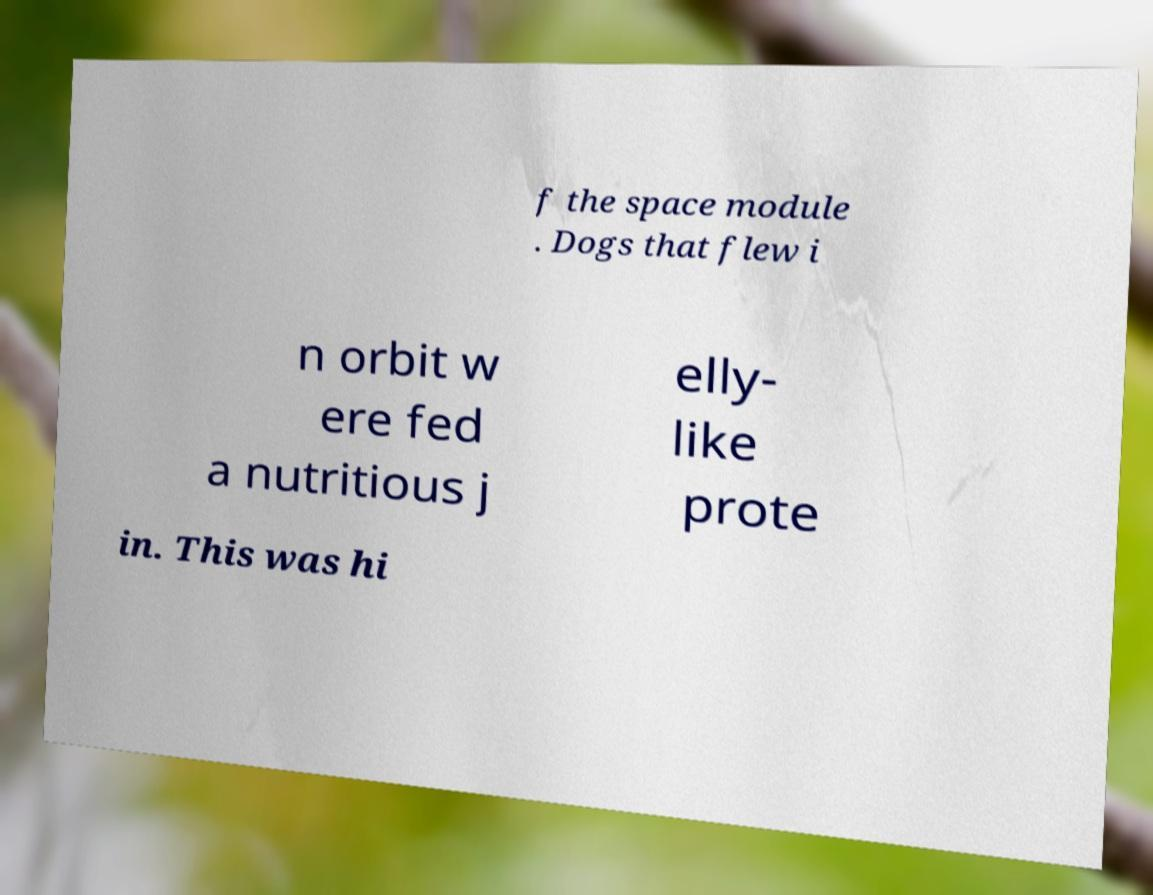Can you read and provide the text displayed in the image?This photo seems to have some interesting text. Can you extract and type it out for me? f the space module . Dogs that flew i n orbit w ere fed a nutritious j elly- like prote in. This was hi 